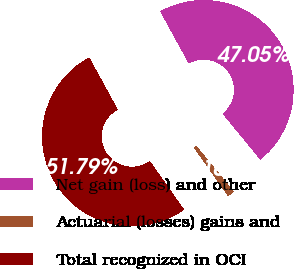Convert chart to OTSL. <chart><loc_0><loc_0><loc_500><loc_500><pie_chart><fcel>Net gain (loss) and other<fcel>Actuarial (losses) gains and<fcel>Total recognized in OCI<nl><fcel>47.05%<fcel>1.16%<fcel>51.8%<nl></chart> 